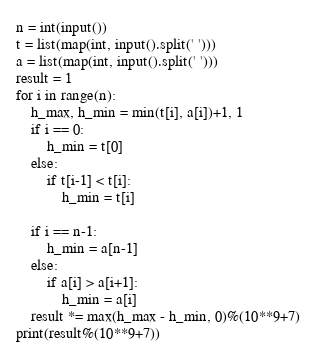Convert code to text. <code><loc_0><loc_0><loc_500><loc_500><_Python_>n = int(input())
t = list(map(int, input().split(' ')))
a = list(map(int, input().split(' ')))
result = 1
for i in range(n):
    h_max, h_min = min(t[i], a[i])+1, 1
    if i == 0:
        h_min = t[0]
    else:
        if t[i-1] < t[i]:
            h_min = t[i]

    if i == n-1:
        h_min = a[n-1] 
    else:
        if a[i] > a[i+1]:
            h_min = a[i]
    result *= max(h_max - h_min, 0)%(10**9+7)
print(result%(10**9+7))</code> 